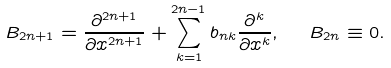<formula> <loc_0><loc_0><loc_500><loc_500>B _ { 2 n + 1 } = \frac { \partial ^ { 2 n + 1 } } { \partial x ^ { 2 n + 1 } } + \sum _ { k = 1 } ^ { 2 n - 1 } b _ { n k } \frac { \partial ^ { k } } { \partial x ^ { k } } , \ \ B _ { 2 n } \equiv 0 .</formula> 